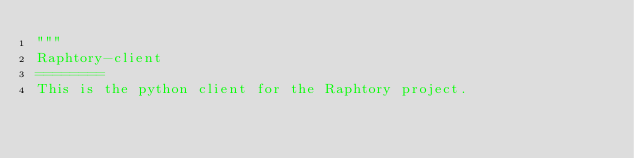Convert code to text. <code><loc_0><loc_0><loc_500><loc_500><_Python_>"""
Raphtory-client
========
This is the python client for the Raphtory project.</code> 